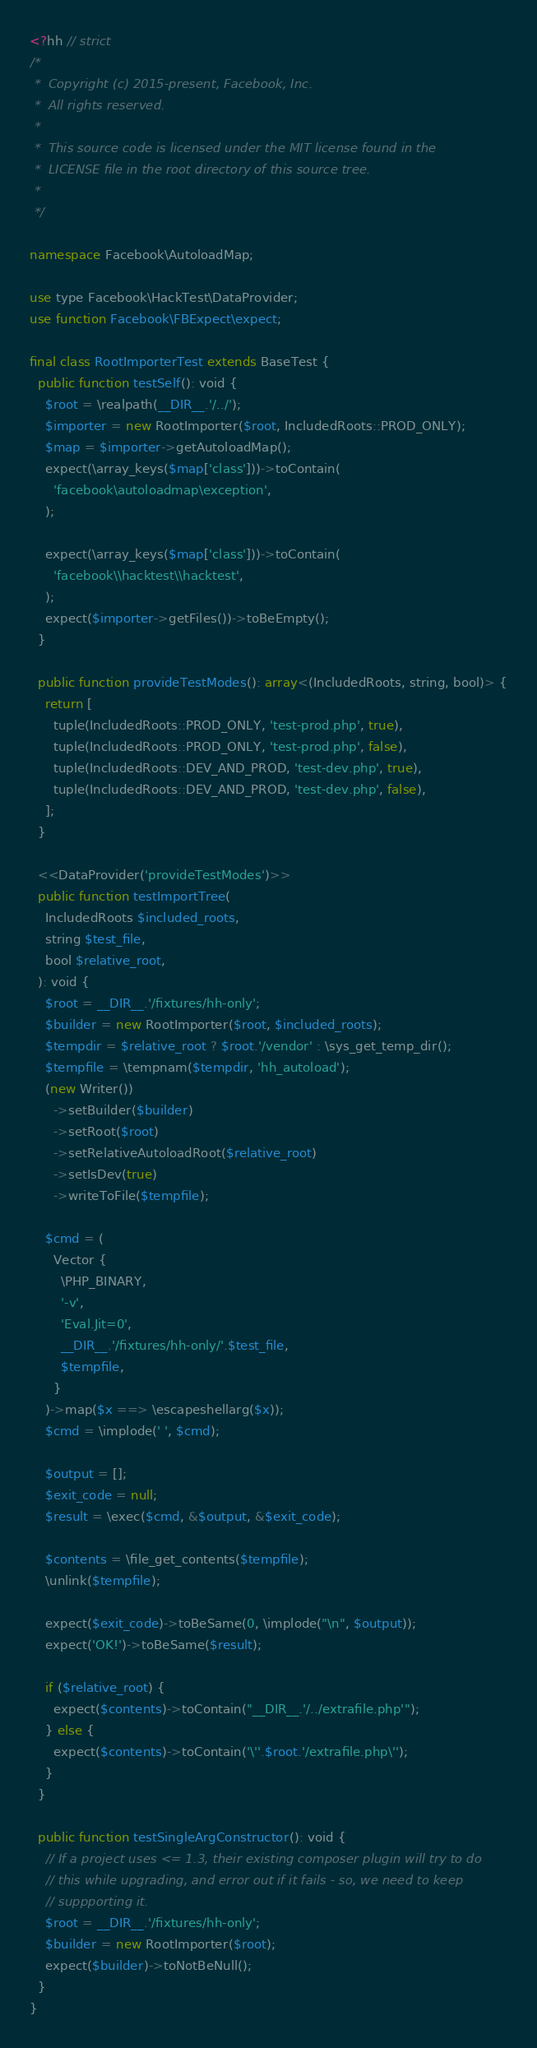<code> <loc_0><loc_0><loc_500><loc_500><_PHP_><?hh // strict
/*
 *  Copyright (c) 2015-present, Facebook, Inc.
 *  All rights reserved.
 *
 *  This source code is licensed under the MIT license found in the
 *  LICENSE file in the root directory of this source tree.
 *
 */

namespace Facebook\AutoloadMap;

use type Facebook\HackTest\DataProvider;
use function Facebook\FBExpect\expect;

final class RootImporterTest extends BaseTest {
  public function testSelf(): void {
    $root = \realpath(__DIR__.'/../');
    $importer = new RootImporter($root, IncludedRoots::PROD_ONLY);
    $map = $importer->getAutoloadMap();
    expect(\array_keys($map['class']))->toContain(
      'facebook\autoloadmap\exception',
    );

    expect(\array_keys($map['class']))->toContain(
      'facebook\\hacktest\\hacktest',
    );
    expect($importer->getFiles())->toBeEmpty();
  }

  public function provideTestModes(): array<(IncludedRoots, string, bool)> {
    return [
      tuple(IncludedRoots::PROD_ONLY, 'test-prod.php', true),
      tuple(IncludedRoots::PROD_ONLY, 'test-prod.php', false),
      tuple(IncludedRoots::DEV_AND_PROD, 'test-dev.php', true),
      tuple(IncludedRoots::DEV_AND_PROD, 'test-dev.php', false),
    ];
  }

  <<DataProvider('provideTestModes')>>
  public function testImportTree(
    IncludedRoots $included_roots,
    string $test_file,
    bool $relative_root,
  ): void {
    $root = __DIR__.'/fixtures/hh-only';
    $builder = new RootImporter($root, $included_roots);
    $tempdir = $relative_root ? $root.'/vendor' : \sys_get_temp_dir();
    $tempfile = \tempnam($tempdir, 'hh_autoload');
    (new Writer())
      ->setBuilder($builder)
      ->setRoot($root)
      ->setRelativeAutoloadRoot($relative_root)
      ->setIsDev(true)
      ->writeToFile($tempfile);

    $cmd = (
      Vector {
        \PHP_BINARY,
        '-v',
        'Eval.Jit=0',
        __DIR__.'/fixtures/hh-only/'.$test_file,
        $tempfile,
      }
    )->map($x ==> \escapeshellarg($x));
    $cmd = \implode(' ', $cmd);

    $output = [];
    $exit_code = null;
    $result = \exec($cmd, &$output, &$exit_code);

    $contents = \file_get_contents($tempfile);
    \unlink($tempfile);

    expect($exit_code)->toBeSame(0, \implode("\n", $output));
    expect('OK!')->toBeSame($result);

    if ($relative_root) {
      expect($contents)->toContain("__DIR__.'/../extrafile.php'");
    } else {
      expect($contents)->toContain('\''.$root.'/extrafile.php\'');
    }
  }

  public function testSingleArgConstructor(): void {
    // If a project uses <= 1.3, their existing composer plugin will try to do
    // this while upgrading, and error out if it fails - so, we need to keep
    // suppporting it.
    $root = __DIR__.'/fixtures/hh-only';
    $builder = new RootImporter($root);
    expect($builder)->toNotBeNull();
  }
}
</code> 